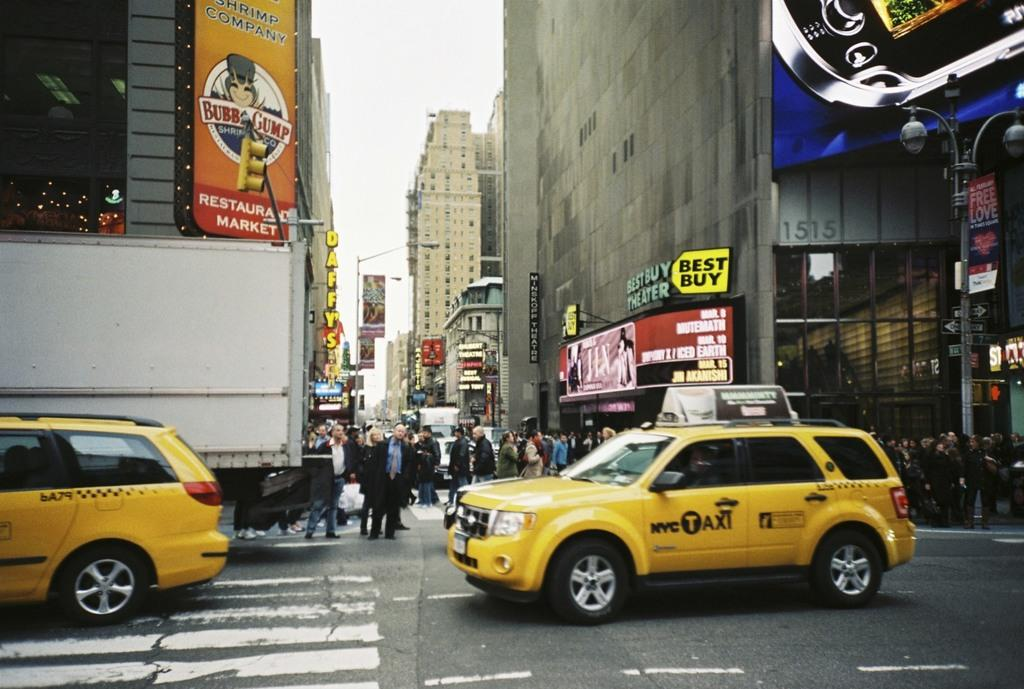<image>
Describe the image concisely. a car that says Taxi on the sign on the street 